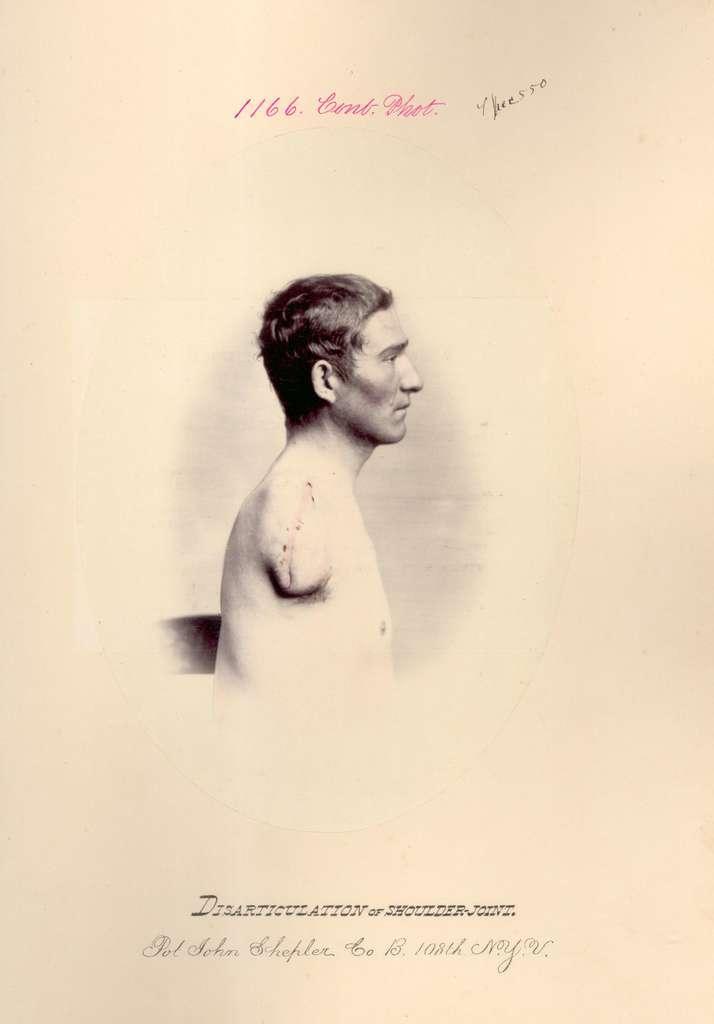Describe this image in one or two sentences. This is an animated image in which there is some text and there is a image of the person. 